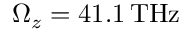Convert formula to latex. <formula><loc_0><loc_0><loc_500><loc_500>\Omega _ { z } = 4 1 . 1 \, T H z</formula> 